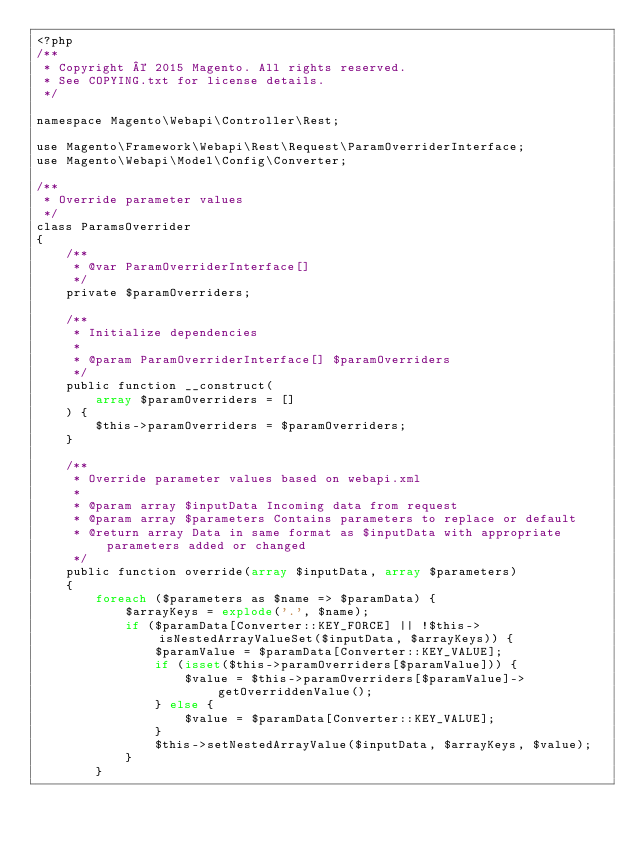Convert code to text. <code><loc_0><loc_0><loc_500><loc_500><_PHP_><?php
/**
 * Copyright © 2015 Magento. All rights reserved.
 * See COPYING.txt for license details.
 */

namespace Magento\Webapi\Controller\Rest;

use Magento\Framework\Webapi\Rest\Request\ParamOverriderInterface;
use Magento\Webapi\Model\Config\Converter;

/**
 * Override parameter values
 */
class ParamsOverrider
{
    /**
     * @var ParamOverriderInterface[]
     */
    private $paramOverriders;

    /**
     * Initialize dependencies
     *
     * @param ParamOverriderInterface[] $paramOverriders
     */
    public function __construct(
        array $paramOverriders = []
    ) {
        $this->paramOverriders = $paramOverriders;
    }

    /**
     * Override parameter values based on webapi.xml
     *
     * @param array $inputData Incoming data from request
     * @param array $parameters Contains parameters to replace or default
     * @return array Data in same format as $inputData with appropriate parameters added or changed
     */
    public function override(array $inputData, array $parameters)
    {
        foreach ($parameters as $name => $paramData) {
            $arrayKeys = explode('.', $name);
            if ($paramData[Converter::KEY_FORCE] || !$this->isNestedArrayValueSet($inputData, $arrayKeys)) {
                $paramValue = $paramData[Converter::KEY_VALUE];
                if (isset($this->paramOverriders[$paramValue])) {
                    $value = $this->paramOverriders[$paramValue]->getOverriddenValue();
                } else {
                    $value = $paramData[Converter::KEY_VALUE];
                }
                $this->setNestedArrayValue($inputData, $arrayKeys, $value);
            }
        }</code> 